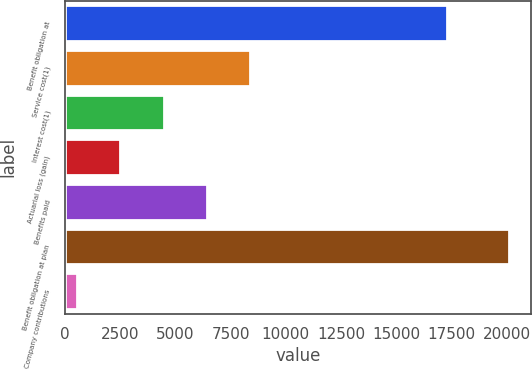<chart> <loc_0><loc_0><loc_500><loc_500><bar_chart><fcel>Benefit obligation at<fcel>Service cost(1)<fcel>Interest cost(1)<fcel>Actuarial loss (gain)<fcel>Benefits paid<fcel>Benefit obligation at plan<fcel>Company contributions<nl><fcel>17300<fcel>8374<fcel>4472<fcel>2521<fcel>6423<fcel>20080<fcel>570<nl></chart> 